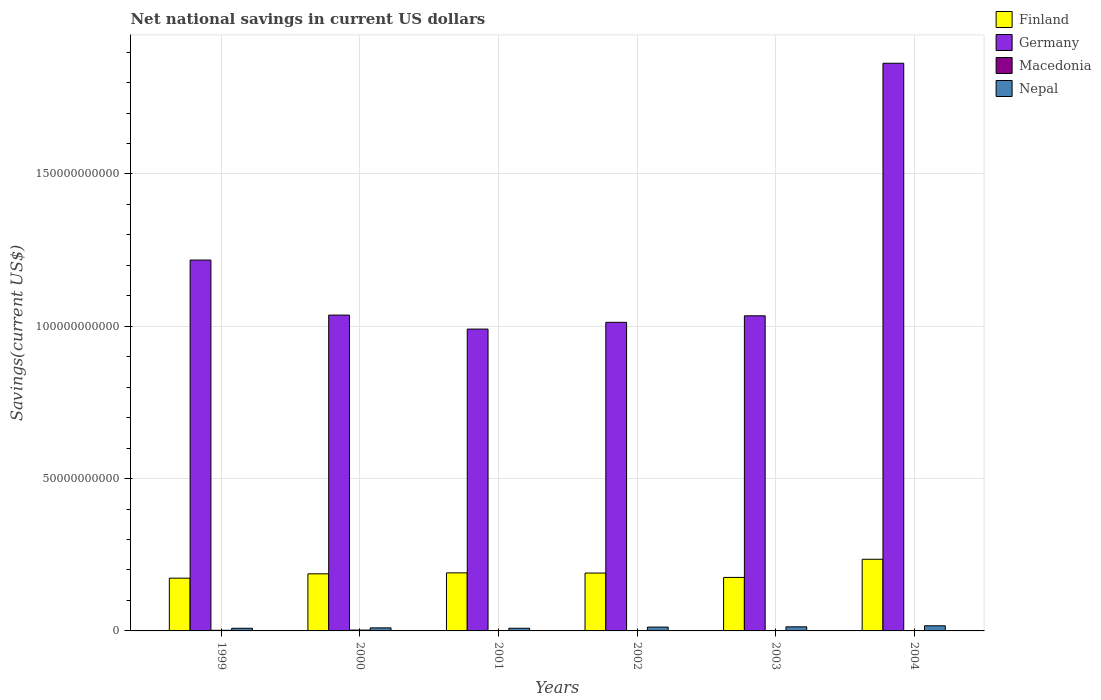How many different coloured bars are there?
Provide a short and direct response. 4. How many groups of bars are there?
Make the answer very short. 6. Are the number of bars on each tick of the X-axis equal?
Make the answer very short. No. How many bars are there on the 5th tick from the left?
Offer a terse response. 3. In how many cases, is the number of bars for a given year not equal to the number of legend labels?
Give a very brief answer. 4. What is the net national savings in Germany in 2004?
Offer a very short reply. 1.86e+11. Across all years, what is the maximum net national savings in Macedonia?
Offer a very short reply. 2.75e+08. Across all years, what is the minimum net national savings in Germany?
Make the answer very short. 9.91e+1. What is the total net national savings in Nepal in the graph?
Provide a short and direct response. 7.04e+09. What is the difference between the net national savings in Finland in 1999 and that in 2004?
Give a very brief answer. -6.20e+09. What is the difference between the net national savings in Finland in 2003 and the net national savings in Germany in 2002?
Give a very brief answer. -8.37e+1. What is the average net national savings in Germany per year?
Your answer should be very brief. 1.19e+11. In the year 2001, what is the difference between the net national savings in Germany and net national savings in Finland?
Your response must be concise. 8.00e+1. In how many years, is the net national savings in Macedonia greater than 40000000000 US$?
Provide a succinct answer. 0. What is the ratio of the net national savings in Finland in 2000 to that in 2001?
Provide a short and direct response. 0.98. Is the net national savings in Nepal in 2001 less than that in 2002?
Keep it short and to the point. Yes. Is the difference between the net national savings in Germany in 2000 and 2001 greater than the difference between the net national savings in Finland in 2000 and 2001?
Your answer should be very brief. Yes. What is the difference between the highest and the second highest net national savings in Germany?
Provide a succinct answer. 6.46e+1. What is the difference between the highest and the lowest net national savings in Macedonia?
Your answer should be very brief. 2.75e+08. In how many years, is the net national savings in Macedonia greater than the average net national savings in Macedonia taken over all years?
Offer a very short reply. 2. Is the sum of the net national savings in Germany in 2000 and 2002 greater than the maximum net national savings in Macedonia across all years?
Ensure brevity in your answer.  Yes. Is it the case that in every year, the sum of the net national savings in Nepal and net national savings in Germany is greater than the net national savings in Finland?
Your response must be concise. Yes. How many bars are there?
Your answer should be compact. 20. How many years are there in the graph?
Your answer should be very brief. 6. What is the difference between two consecutive major ticks on the Y-axis?
Offer a terse response. 5.00e+1. Where does the legend appear in the graph?
Provide a short and direct response. Top right. How many legend labels are there?
Keep it short and to the point. 4. How are the legend labels stacked?
Give a very brief answer. Vertical. What is the title of the graph?
Your answer should be compact. Net national savings in current US dollars. Does "Malawi" appear as one of the legend labels in the graph?
Offer a very short reply. No. What is the label or title of the X-axis?
Your answer should be very brief. Years. What is the label or title of the Y-axis?
Give a very brief answer. Savings(current US$). What is the Savings(current US$) of Finland in 1999?
Offer a terse response. 1.73e+1. What is the Savings(current US$) in Germany in 1999?
Provide a short and direct response. 1.22e+11. What is the Savings(current US$) of Macedonia in 1999?
Give a very brief answer. 2.06e+08. What is the Savings(current US$) in Nepal in 1999?
Ensure brevity in your answer.  8.70e+08. What is the Savings(current US$) of Finland in 2000?
Provide a short and direct response. 1.87e+1. What is the Savings(current US$) of Germany in 2000?
Your answer should be compact. 1.04e+11. What is the Savings(current US$) in Macedonia in 2000?
Keep it short and to the point. 2.75e+08. What is the Savings(current US$) of Nepal in 2000?
Provide a succinct answer. 1.00e+09. What is the Savings(current US$) in Finland in 2001?
Offer a very short reply. 1.91e+1. What is the Savings(current US$) of Germany in 2001?
Ensure brevity in your answer.  9.91e+1. What is the Savings(current US$) in Nepal in 2001?
Your answer should be very brief. 8.78e+08. What is the Savings(current US$) in Finland in 2002?
Your answer should be very brief. 1.90e+1. What is the Savings(current US$) in Germany in 2002?
Provide a succinct answer. 1.01e+11. What is the Savings(current US$) in Nepal in 2002?
Offer a terse response. 1.26e+09. What is the Savings(current US$) of Finland in 2003?
Offer a terse response. 1.76e+1. What is the Savings(current US$) in Germany in 2003?
Make the answer very short. 1.03e+11. What is the Savings(current US$) in Macedonia in 2003?
Give a very brief answer. 0. What is the Savings(current US$) in Nepal in 2003?
Your answer should be very brief. 1.35e+09. What is the Savings(current US$) of Finland in 2004?
Your answer should be compact. 2.35e+1. What is the Savings(current US$) of Germany in 2004?
Your answer should be very brief. 1.86e+11. What is the Savings(current US$) in Nepal in 2004?
Provide a succinct answer. 1.68e+09. Across all years, what is the maximum Savings(current US$) of Finland?
Provide a succinct answer. 2.35e+1. Across all years, what is the maximum Savings(current US$) in Germany?
Your response must be concise. 1.86e+11. Across all years, what is the maximum Savings(current US$) in Macedonia?
Your response must be concise. 2.75e+08. Across all years, what is the maximum Savings(current US$) in Nepal?
Ensure brevity in your answer.  1.68e+09. Across all years, what is the minimum Savings(current US$) of Finland?
Your answer should be compact. 1.73e+1. Across all years, what is the minimum Savings(current US$) in Germany?
Your answer should be very brief. 9.91e+1. Across all years, what is the minimum Savings(current US$) of Macedonia?
Offer a terse response. 0. Across all years, what is the minimum Savings(current US$) in Nepal?
Your answer should be compact. 8.70e+08. What is the total Savings(current US$) of Finland in the graph?
Your answer should be very brief. 1.15e+11. What is the total Savings(current US$) in Germany in the graph?
Your answer should be compact. 7.16e+11. What is the total Savings(current US$) of Macedonia in the graph?
Your answer should be compact. 4.80e+08. What is the total Savings(current US$) in Nepal in the graph?
Provide a short and direct response. 7.04e+09. What is the difference between the Savings(current US$) of Finland in 1999 and that in 2000?
Make the answer very short. -1.42e+09. What is the difference between the Savings(current US$) in Germany in 1999 and that in 2000?
Give a very brief answer. 1.81e+1. What is the difference between the Savings(current US$) in Macedonia in 1999 and that in 2000?
Your answer should be compact. -6.90e+07. What is the difference between the Savings(current US$) in Nepal in 1999 and that in 2000?
Provide a succinct answer. -1.33e+08. What is the difference between the Savings(current US$) of Finland in 1999 and that in 2001?
Keep it short and to the point. -1.74e+09. What is the difference between the Savings(current US$) in Germany in 1999 and that in 2001?
Provide a short and direct response. 2.27e+1. What is the difference between the Savings(current US$) of Nepal in 1999 and that in 2001?
Provide a succinct answer. -7.66e+06. What is the difference between the Savings(current US$) in Finland in 1999 and that in 2002?
Give a very brief answer. -1.68e+09. What is the difference between the Savings(current US$) in Germany in 1999 and that in 2002?
Your answer should be very brief. 2.04e+1. What is the difference between the Savings(current US$) in Nepal in 1999 and that in 2002?
Make the answer very short. -3.90e+08. What is the difference between the Savings(current US$) in Finland in 1999 and that in 2003?
Ensure brevity in your answer.  -2.43e+08. What is the difference between the Savings(current US$) in Germany in 1999 and that in 2003?
Your answer should be compact. 1.83e+1. What is the difference between the Savings(current US$) of Nepal in 1999 and that in 2003?
Offer a terse response. -4.75e+08. What is the difference between the Savings(current US$) in Finland in 1999 and that in 2004?
Ensure brevity in your answer.  -6.20e+09. What is the difference between the Savings(current US$) in Germany in 1999 and that in 2004?
Offer a very short reply. -6.46e+1. What is the difference between the Savings(current US$) in Nepal in 1999 and that in 2004?
Ensure brevity in your answer.  -8.14e+08. What is the difference between the Savings(current US$) in Finland in 2000 and that in 2001?
Your answer should be very brief. -3.20e+08. What is the difference between the Savings(current US$) in Germany in 2000 and that in 2001?
Give a very brief answer. 4.59e+09. What is the difference between the Savings(current US$) of Nepal in 2000 and that in 2001?
Ensure brevity in your answer.  1.26e+08. What is the difference between the Savings(current US$) of Finland in 2000 and that in 2002?
Ensure brevity in your answer.  -2.53e+08. What is the difference between the Savings(current US$) in Germany in 2000 and that in 2002?
Offer a very short reply. 2.37e+09. What is the difference between the Savings(current US$) of Nepal in 2000 and that in 2002?
Your response must be concise. -2.57e+08. What is the difference between the Savings(current US$) in Finland in 2000 and that in 2003?
Provide a short and direct response. 1.18e+09. What is the difference between the Savings(current US$) of Germany in 2000 and that in 2003?
Make the answer very short. 2.28e+08. What is the difference between the Savings(current US$) in Nepal in 2000 and that in 2003?
Offer a terse response. -3.42e+08. What is the difference between the Savings(current US$) in Finland in 2000 and that in 2004?
Your answer should be very brief. -4.78e+09. What is the difference between the Savings(current US$) of Germany in 2000 and that in 2004?
Provide a short and direct response. -8.27e+1. What is the difference between the Savings(current US$) of Nepal in 2000 and that in 2004?
Provide a short and direct response. -6.81e+08. What is the difference between the Savings(current US$) of Finland in 2001 and that in 2002?
Provide a short and direct response. 6.72e+07. What is the difference between the Savings(current US$) of Germany in 2001 and that in 2002?
Your answer should be very brief. -2.22e+09. What is the difference between the Savings(current US$) in Nepal in 2001 and that in 2002?
Your answer should be very brief. -3.83e+08. What is the difference between the Savings(current US$) in Finland in 2001 and that in 2003?
Your answer should be compact. 1.50e+09. What is the difference between the Savings(current US$) of Germany in 2001 and that in 2003?
Your answer should be very brief. -4.36e+09. What is the difference between the Savings(current US$) in Nepal in 2001 and that in 2003?
Offer a very short reply. -4.67e+08. What is the difference between the Savings(current US$) of Finland in 2001 and that in 2004?
Your answer should be very brief. -4.46e+09. What is the difference between the Savings(current US$) in Germany in 2001 and that in 2004?
Offer a terse response. -8.73e+1. What is the difference between the Savings(current US$) of Nepal in 2001 and that in 2004?
Your answer should be compact. -8.07e+08. What is the difference between the Savings(current US$) of Finland in 2002 and that in 2003?
Your response must be concise. 1.43e+09. What is the difference between the Savings(current US$) of Germany in 2002 and that in 2003?
Provide a short and direct response. -2.14e+09. What is the difference between the Savings(current US$) in Nepal in 2002 and that in 2003?
Your answer should be compact. -8.45e+07. What is the difference between the Savings(current US$) in Finland in 2002 and that in 2004?
Make the answer very short. -4.53e+09. What is the difference between the Savings(current US$) in Germany in 2002 and that in 2004?
Keep it short and to the point. -8.50e+1. What is the difference between the Savings(current US$) in Nepal in 2002 and that in 2004?
Ensure brevity in your answer.  -4.24e+08. What is the difference between the Savings(current US$) of Finland in 2003 and that in 2004?
Keep it short and to the point. -5.96e+09. What is the difference between the Savings(current US$) of Germany in 2003 and that in 2004?
Your answer should be compact. -8.29e+1. What is the difference between the Savings(current US$) of Nepal in 2003 and that in 2004?
Provide a short and direct response. -3.40e+08. What is the difference between the Savings(current US$) of Finland in 1999 and the Savings(current US$) of Germany in 2000?
Your answer should be compact. -8.63e+1. What is the difference between the Savings(current US$) of Finland in 1999 and the Savings(current US$) of Macedonia in 2000?
Keep it short and to the point. 1.70e+1. What is the difference between the Savings(current US$) of Finland in 1999 and the Savings(current US$) of Nepal in 2000?
Your answer should be very brief. 1.63e+1. What is the difference between the Savings(current US$) in Germany in 1999 and the Savings(current US$) in Macedonia in 2000?
Your answer should be very brief. 1.21e+11. What is the difference between the Savings(current US$) in Germany in 1999 and the Savings(current US$) in Nepal in 2000?
Provide a succinct answer. 1.21e+11. What is the difference between the Savings(current US$) of Macedonia in 1999 and the Savings(current US$) of Nepal in 2000?
Your response must be concise. -7.98e+08. What is the difference between the Savings(current US$) of Finland in 1999 and the Savings(current US$) of Germany in 2001?
Keep it short and to the point. -8.18e+1. What is the difference between the Savings(current US$) of Finland in 1999 and the Savings(current US$) of Nepal in 2001?
Give a very brief answer. 1.64e+1. What is the difference between the Savings(current US$) in Germany in 1999 and the Savings(current US$) in Nepal in 2001?
Offer a terse response. 1.21e+11. What is the difference between the Savings(current US$) of Macedonia in 1999 and the Savings(current US$) of Nepal in 2001?
Make the answer very short. -6.72e+08. What is the difference between the Savings(current US$) in Finland in 1999 and the Savings(current US$) in Germany in 2002?
Offer a very short reply. -8.40e+1. What is the difference between the Savings(current US$) of Finland in 1999 and the Savings(current US$) of Nepal in 2002?
Your answer should be compact. 1.61e+1. What is the difference between the Savings(current US$) in Germany in 1999 and the Savings(current US$) in Nepal in 2002?
Give a very brief answer. 1.20e+11. What is the difference between the Savings(current US$) in Macedonia in 1999 and the Savings(current US$) in Nepal in 2002?
Provide a short and direct response. -1.06e+09. What is the difference between the Savings(current US$) of Finland in 1999 and the Savings(current US$) of Germany in 2003?
Your answer should be very brief. -8.61e+1. What is the difference between the Savings(current US$) of Finland in 1999 and the Savings(current US$) of Nepal in 2003?
Provide a succinct answer. 1.60e+1. What is the difference between the Savings(current US$) in Germany in 1999 and the Savings(current US$) in Nepal in 2003?
Your answer should be very brief. 1.20e+11. What is the difference between the Savings(current US$) in Macedonia in 1999 and the Savings(current US$) in Nepal in 2003?
Provide a short and direct response. -1.14e+09. What is the difference between the Savings(current US$) in Finland in 1999 and the Savings(current US$) in Germany in 2004?
Provide a succinct answer. -1.69e+11. What is the difference between the Savings(current US$) of Finland in 1999 and the Savings(current US$) of Nepal in 2004?
Offer a terse response. 1.56e+1. What is the difference between the Savings(current US$) in Germany in 1999 and the Savings(current US$) in Nepal in 2004?
Offer a very short reply. 1.20e+11. What is the difference between the Savings(current US$) of Macedonia in 1999 and the Savings(current US$) of Nepal in 2004?
Keep it short and to the point. -1.48e+09. What is the difference between the Savings(current US$) in Finland in 2000 and the Savings(current US$) in Germany in 2001?
Make the answer very short. -8.03e+1. What is the difference between the Savings(current US$) of Finland in 2000 and the Savings(current US$) of Nepal in 2001?
Keep it short and to the point. 1.79e+1. What is the difference between the Savings(current US$) in Germany in 2000 and the Savings(current US$) in Nepal in 2001?
Your answer should be very brief. 1.03e+11. What is the difference between the Savings(current US$) in Macedonia in 2000 and the Savings(current US$) in Nepal in 2001?
Keep it short and to the point. -6.03e+08. What is the difference between the Savings(current US$) of Finland in 2000 and the Savings(current US$) of Germany in 2002?
Offer a terse response. -8.26e+1. What is the difference between the Savings(current US$) of Finland in 2000 and the Savings(current US$) of Nepal in 2002?
Keep it short and to the point. 1.75e+1. What is the difference between the Savings(current US$) in Germany in 2000 and the Savings(current US$) in Nepal in 2002?
Provide a succinct answer. 1.02e+11. What is the difference between the Savings(current US$) of Macedonia in 2000 and the Savings(current US$) of Nepal in 2002?
Make the answer very short. -9.86e+08. What is the difference between the Savings(current US$) of Finland in 2000 and the Savings(current US$) of Germany in 2003?
Provide a short and direct response. -8.47e+1. What is the difference between the Savings(current US$) in Finland in 2000 and the Savings(current US$) in Nepal in 2003?
Your answer should be compact. 1.74e+1. What is the difference between the Savings(current US$) in Germany in 2000 and the Savings(current US$) in Nepal in 2003?
Provide a short and direct response. 1.02e+11. What is the difference between the Savings(current US$) in Macedonia in 2000 and the Savings(current US$) in Nepal in 2003?
Make the answer very short. -1.07e+09. What is the difference between the Savings(current US$) in Finland in 2000 and the Savings(current US$) in Germany in 2004?
Give a very brief answer. -1.68e+11. What is the difference between the Savings(current US$) of Finland in 2000 and the Savings(current US$) of Nepal in 2004?
Give a very brief answer. 1.71e+1. What is the difference between the Savings(current US$) of Germany in 2000 and the Savings(current US$) of Nepal in 2004?
Keep it short and to the point. 1.02e+11. What is the difference between the Savings(current US$) in Macedonia in 2000 and the Savings(current US$) in Nepal in 2004?
Keep it short and to the point. -1.41e+09. What is the difference between the Savings(current US$) in Finland in 2001 and the Savings(current US$) in Germany in 2002?
Offer a very short reply. -8.22e+1. What is the difference between the Savings(current US$) in Finland in 2001 and the Savings(current US$) in Nepal in 2002?
Keep it short and to the point. 1.78e+1. What is the difference between the Savings(current US$) of Germany in 2001 and the Savings(current US$) of Nepal in 2002?
Your answer should be compact. 9.78e+1. What is the difference between the Savings(current US$) in Finland in 2001 and the Savings(current US$) in Germany in 2003?
Your answer should be very brief. -8.44e+1. What is the difference between the Savings(current US$) in Finland in 2001 and the Savings(current US$) in Nepal in 2003?
Give a very brief answer. 1.77e+1. What is the difference between the Savings(current US$) in Germany in 2001 and the Savings(current US$) in Nepal in 2003?
Provide a short and direct response. 9.77e+1. What is the difference between the Savings(current US$) in Finland in 2001 and the Savings(current US$) in Germany in 2004?
Your answer should be very brief. -1.67e+11. What is the difference between the Savings(current US$) of Finland in 2001 and the Savings(current US$) of Nepal in 2004?
Ensure brevity in your answer.  1.74e+1. What is the difference between the Savings(current US$) in Germany in 2001 and the Savings(current US$) in Nepal in 2004?
Your response must be concise. 9.74e+1. What is the difference between the Savings(current US$) of Finland in 2002 and the Savings(current US$) of Germany in 2003?
Offer a terse response. -8.44e+1. What is the difference between the Savings(current US$) of Finland in 2002 and the Savings(current US$) of Nepal in 2003?
Make the answer very short. 1.76e+1. What is the difference between the Savings(current US$) in Germany in 2002 and the Savings(current US$) in Nepal in 2003?
Offer a terse response. 9.99e+1. What is the difference between the Savings(current US$) in Finland in 2002 and the Savings(current US$) in Germany in 2004?
Provide a short and direct response. -1.67e+11. What is the difference between the Savings(current US$) in Finland in 2002 and the Savings(current US$) in Nepal in 2004?
Your response must be concise. 1.73e+1. What is the difference between the Savings(current US$) of Germany in 2002 and the Savings(current US$) of Nepal in 2004?
Your response must be concise. 9.96e+1. What is the difference between the Savings(current US$) of Finland in 2003 and the Savings(current US$) of Germany in 2004?
Keep it short and to the point. -1.69e+11. What is the difference between the Savings(current US$) in Finland in 2003 and the Savings(current US$) in Nepal in 2004?
Keep it short and to the point. 1.59e+1. What is the difference between the Savings(current US$) of Germany in 2003 and the Savings(current US$) of Nepal in 2004?
Offer a very short reply. 1.02e+11. What is the average Savings(current US$) in Finland per year?
Offer a very short reply. 1.92e+1. What is the average Savings(current US$) in Germany per year?
Offer a terse response. 1.19e+11. What is the average Savings(current US$) in Macedonia per year?
Make the answer very short. 8.00e+07. What is the average Savings(current US$) in Nepal per year?
Keep it short and to the point. 1.17e+09. In the year 1999, what is the difference between the Savings(current US$) of Finland and Savings(current US$) of Germany?
Give a very brief answer. -1.04e+11. In the year 1999, what is the difference between the Savings(current US$) in Finland and Savings(current US$) in Macedonia?
Provide a short and direct response. 1.71e+1. In the year 1999, what is the difference between the Savings(current US$) of Finland and Savings(current US$) of Nepal?
Provide a short and direct response. 1.64e+1. In the year 1999, what is the difference between the Savings(current US$) of Germany and Savings(current US$) of Macedonia?
Make the answer very short. 1.22e+11. In the year 1999, what is the difference between the Savings(current US$) of Germany and Savings(current US$) of Nepal?
Offer a terse response. 1.21e+11. In the year 1999, what is the difference between the Savings(current US$) of Macedonia and Savings(current US$) of Nepal?
Your answer should be compact. -6.65e+08. In the year 2000, what is the difference between the Savings(current US$) in Finland and Savings(current US$) in Germany?
Offer a terse response. -8.49e+1. In the year 2000, what is the difference between the Savings(current US$) of Finland and Savings(current US$) of Macedonia?
Offer a terse response. 1.85e+1. In the year 2000, what is the difference between the Savings(current US$) of Finland and Savings(current US$) of Nepal?
Your answer should be very brief. 1.77e+1. In the year 2000, what is the difference between the Savings(current US$) in Germany and Savings(current US$) in Macedonia?
Offer a terse response. 1.03e+11. In the year 2000, what is the difference between the Savings(current US$) of Germany and Savings(current US$) of Nepal?
Your answer should be very brief. 1.03e+11. In the year 2000, what is the difference between the Savings(current US$) in Macedonia and Savings(current US$) in Nepal?
Ensure brevity in your answer.  -7.29e+08. In the year 2001, what is the difference between the Savings(current US$) of Finland and Savings(current US$) of Germany?
Your answer should be compact. -8.00e+1. In the year 2001, what is the difference between the Savings(current US$) in Finland and Savings(current US$) in Nepal?
Ensure brevity in your answer.  1.82e+1. In the year 2001, what is the difference between the Savings(current US$) of Germany and Savings(current US$) of Nepal?
Provide a short and direct response. 9.82e+1. In the year 2002, what is the difference between the Savings(current US$) in Finland and Savings(current US$) in Germany?
Provide a succinct answer. -8.23e+1. In the year 2002, what is the difference between the Savings(current US$) in Finland and Savings(current US$) in Nepal?
Offer a very short reply. 1.77e+1. In the year 2002, what is the difference between the Savings(current US$) of Germany and Savings(current US$) of Nepal?
Your answer should be compact. 1.00e+11. In the year 2003, what is the difference between the Savings(current US$) in Finland and Savings(current US$) in Germany?
Offer a terse response. -8.59e+1. In the year 2003, what is the difference between the Savings(current US$) of Finland and Savings(current US$) of Nepal?
Give a very brief answer. 1.62e+1. In the year 2003, what is the difference between the Savings(current US$) in Germany and Savings(current US$) in Nepal?
Ensure brevity in your answer.  1.02e+11. In the year 2004, what is the difference between the Savings(current US$) of Finland and Savings(current US$) of Germany?
Make the answer very short. -1.63e+11. In the year 2004, what is the difference between the Savings(current US$) in Finland and Savings(current US$) in Nepal?
Make the answer very short. 2.18e+1. In the year 2004, what is the difference between the Savings(current US$) in Germany and Savings(current US$) in Nepal?
Keep it short and to the point. 1.85e+11. What is the ratio of the Savings(current US$) in Finland in 1999 to that in 2000?
Offer a very short reply. 0.92. What is the ratio of the Savings(current US$) in Germany in 1999 to that in 2000?
Ensure brevity in your answer.  1.17. What is the ratio of the Savings(current US$) in Macedonia in 1999 to that in 2000?
Your answer should be compact. 0.75. What is the ratio of the Savings(current US$) in Nepal in 1999 to that in 2000?
Keep it short and to the point. 0.87. What is the ratio of the Savings(current US$) in Finland in 1999 to that in 2001?
Keep it short and to the point. 0.91. What is the ratio of the Savings(current US$) in Germany in 1999 to that in 2001?
Offer a terse response. 1.23. What is the ratio of the Savings(current US$) of Finland in 1999 to that in 2002?
Offer a terse response. 0.91. What is the ratio of the Savings(current US$) in Germany in 1999 to that in 2002?
Provide a succinct answer. 1.2. What is the ratio of the Savings(current US$) of Nepal in 1999 to that in 2002?
Your answer should be compact. 0.69. What is the ratio of the Savings(current US$) of Finland in 1999 to that in 2003?
Give a very brief answer. 0.99. What is the ratio of the Savings(current US$) in Germany in 1999 to that in 2003?
Offer a very short reply. 1.18. What is the ratio of the Savings(current US$) of Nepal in 1999 to that in 2003?
Your answer should be compact. 0.65. What is the ratio of the Savings(current US$) in Finland in 1999 to that in 2004?
Keep it short and to the point. 0.74. What is the ratio of the Savings(current US$) of Germany in 1999 to that in 2004?
Offer a terse response. 0.65. What is the ratio of the Savings(current US$) in Nepal in 1999 to that in 2004?
Give a very brief answer. 0.52. What is the ratio of the Savings(current US$) in Finland in 2000 to that in 2001?
Ensure brevity in your answer.  0.98. What is the ratio of the Savings(current US$) in Germany in 2000 to that in 2001?
Your response must be concise. 1.05. What is the ratio of the Savings(current US$) of Nepal in 2000 to that in 2001?
Provide a short and direct response. 1.14. What is the ratio of the Savings(current US$) in Finland in 2000 to that in 2002?
Give a very brief answer. 0.99. What is the ratio of the Savings(current US$) in Germany in 2000 to that in 2002?
Keep it short and to the point. 1.02. What is the ratio of the Savings(current US$) of Nepal in 2000 to that in 2002?
Provide a short and direct response. 0.8. What is the ratio of the Savings(current US$) in Finland in 2000 to that in 2003?
Keep it short and to the point. 1.07. What is the ratio of the Savings(current US$) in Germany in 2000 to that in 2003?
Your answer should be compact. 1. What is the ratio of the Savings(current US$) of Nepal in 2000 to that in 2003?
Your answer should be compact. 0.75. What is the ratio of the Savings(current US$) of Finland in 2000 to that in 2004?
Make the answer very short. 0.8. What is the ratio of the Savings(current US$) of Germany in 2000 to that in 2004?
Your answer should be compact. 0.56. What is the ratio of the Savings(current US$) of Nepal in 2000 to that in 2004?
Offer a terse response. 0.6. What is the ratio of the Savings(current US$) of Finland in 2001 to that in 2002?
Offer a very short reply. 1. What is the ratio of the Savings(current US$) of Germany in 2001 to that in 2002?
Ensure brevity in your answer.  0.98. What is the ratio of the Savings(current US$) of Nepal in 2001 to that in 2002?
Offer a very short reply. 0.7. What is the ratio of the Savings(current US$) of Finland in 2001 to that in 2003?
Your answer should be compact. 1.09. What is the ratio of the Savings(current US$) in Germany in 2001 to that in 2003?
Provide a short and direct response. 0.96. What is the ratio of the Savings(current US$) of Nepal in 2001 to that in 2003?
Offer a terse response. 0.65. What is the ratio of the Savings(current US$) of Finland in 2001 to that in 2004?
Provide a succinct answer. 0.81. What is the ratio of the Savings(current US$) of Germany in 2001 to that in 2004?
Offer a very short reply. 0.53. What is the ratio of the Savings(current US$) of Nepal in 2001 to that in 2004?
Keep it short and to the point. 0.52. What is the ratio of the Savings(current US$) of Finland in 2002 to that in 2003?
Your answer should be very brief. 1.08. What is the ratio of the Savings(current US$) in Germany in 2002 to that in 2003?
Your answer should be compact. 0.98. What is the ratio of the Savings(current US$) of Nepal in 2002 to that in 2003?
Keep it short and to the point. 0.94. What is the ratio of the Savings(current US$) in Finland in 2002 to that in 2004?
Your response must be concise. 0.81. What is the ratio of the Savings(current US$) in Germany in 2002 to that in 2004?
Keep it short and to the point. 0.54. What is the ratio of the Savings(current US$) of Nepal in 2002 to that in 2004?
Offer a terse response. 0.75. What is the ratio of the Savings(current US$) in Finland in 2003 to that in 2004?
Provide a short and direct response. 0.75. What is the ratio of the Savings(current US$) in Germany in 2003 to that in 2004?
Provide a short and direct response. 0.56. What is the ratio of the Savings(current US$) in Nepal in 2003 to that in 2004?
Your response must be concise. 0.8. What is the difference between the highest and the second highest Savings(current US$) in Finland?
Your response must be concise. 4.46e+09. What is the difference between the highest and the second highest Savings(current US$) in Germany?
Your response must be concise. 6.46e+1. What is the difference between the highest and the second highest Savings(current US$) in Nepal?
Give a very brief answer. 3.40e+08. What is the difference between the highest and the lowest Savings(current US$) of Finland?
Offer a terse response. 6.20e+09. What is the difference between the highest and the lowest Savings(current US$) in Germany?
Your answer should be very brief. 8.73e+1. What is the difference between the highest and the lowest Savings(current US$) in Macedonia?
Provide a succinct answer. 2.75e+08. What is the difference between the highest and the lowest Savings(current US$) in Nepal?
Keep it short and to the point. 8.14e+08. 